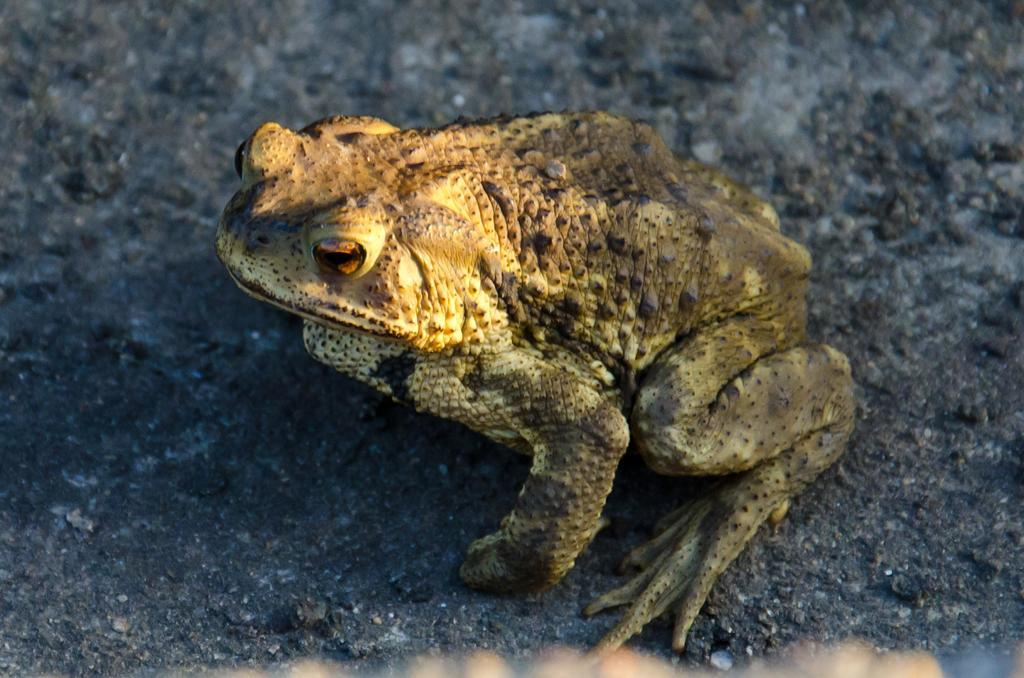What type of animal is in the image? There is a frog in the image. Where is the frog located in the image? The frog is on the ground. What type of store can be seen in the background of the image? There is no store present in the image; it only features a frog on the ground. 